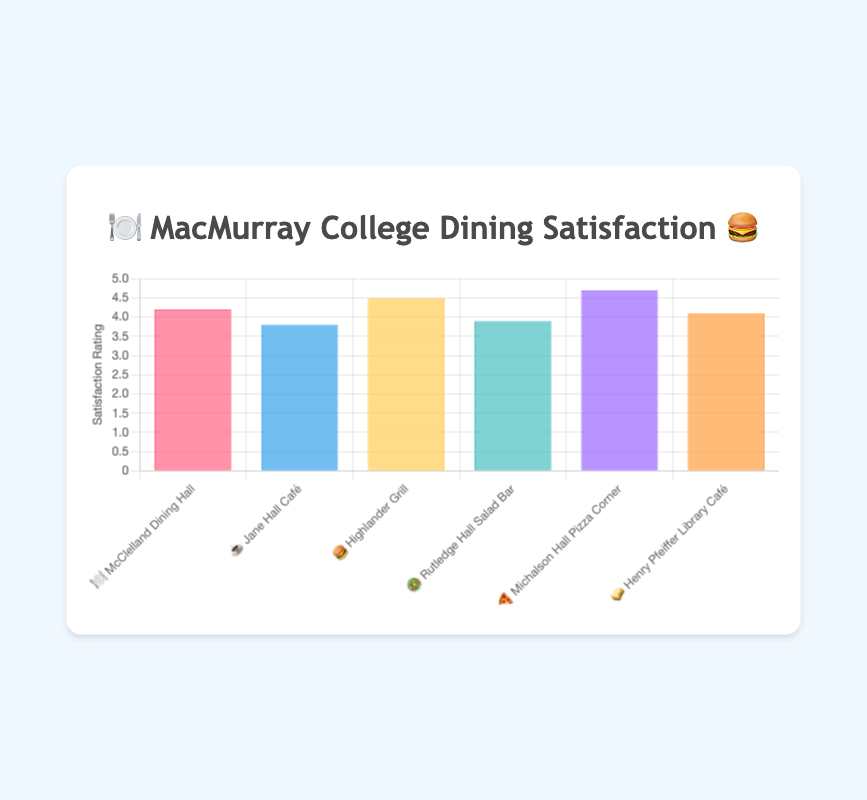What's the title of the chart? The title is located at the top-center of the chart and reads "🍽️ MacMurray College Dining Satisfaction 🍔".
Answer: 🍽️ MacMurray College Dining Satisfaction 🍔 What is the satisfaction rating of Michalson Hall Pizza Corner? Look for the bar labeled with "🍕 Michalson Hall Pizza Corner" and observe the height of the bar on the y-axis, which indicates a rating of 4.7.
Answer: 4.7 Which dining option has the lowest satisfaction rating? Find the shortest bar in the chart, which corresponds to "☕ Jane Hall Café" with a rating of 3.8.
Answer: Jane Hall Café Rank the dining options from highest to lowest satisfaction rating. Compare the heights of all the bars. The order from highest to lowest is: 🍕 Michalson Hall Pizza Corner (4.7), 🍔 Highlander Grill (4.5), 🍽️ McClelland Dining Hall (4.2), 🥪 Henry Pfeiffer Library Café (4.1), 🥗 Rutledge Hall Salad Bar (3.9), and ☕ Jane Hall Café (3.8).
Answer: 🍕, 🍔, 🍽️, 🥪, 🥗, ☕ What is the average satisfaction rating of all the dining options? Add all the ratings together (4.2 + 3.8 + 4.5 + 3.9 + 4.7 + 4.1) and divide by the number of options (6): (25.2 / 6) = 4.2.
Answer: 4.2 How much higher is the satisfaction rating of Highlander Grill compared to Jane Hall Café? Subtract the rating of Jane Hall Café (3.8) from Highlander Grill (4.5): (4.5 - 3.8) = 0.7.
Answer: 0.7 Which dining options have a satisfaction rating above 4.0? Identify the bars with a height above the 4.0 mark on the y-axis: 🍽️ McClelland Dining Hall (4.2), 🍔 Highlander Grill (4.5), 🍕 Michalson Hall Pizza Corner (4.7), and 🥪 Henry Pfeiffer Library Café (4.1).
Answer: 🍽️, 🍔, 🍕, 🥪 